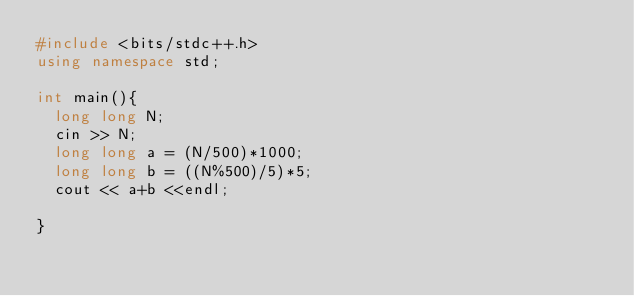Convert code to text. <code><loc_0><loc_0><loc_500><loc_500><_C++_>#include <bits/stdc++.h>
using namespace std;

int main(){
  long long N;
  cin >> N;
  long long a = (N/500)*1000;
  long long b = ((N%500)/5)*5;
  cout << a+b <<endl;
  
}</code> 